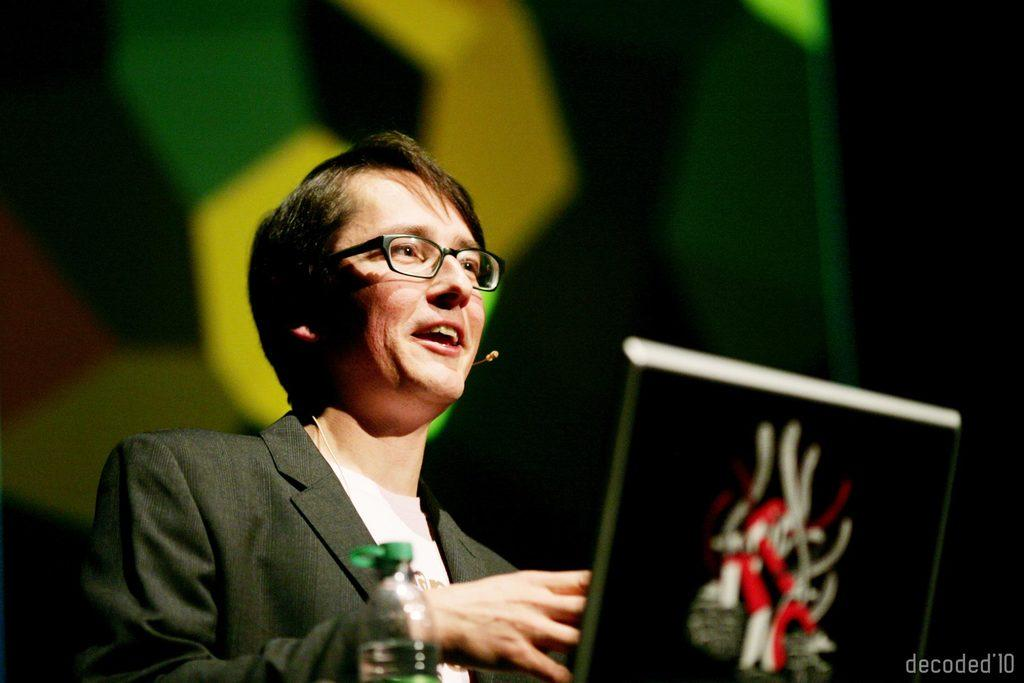Who is the main subject in the image? There is a person in the image. What can be seen on the person's face? The person is wearing spectacles. What object is in front of the person? There is a laptop and a bottle in front of the person. Can you describe the background of the image? The background of the image is blurry. What type of food is the person's owner feeding them in the image? There is no indication of an owner or food in the image; it only features a person with a laptop and a bottle in front of them. 